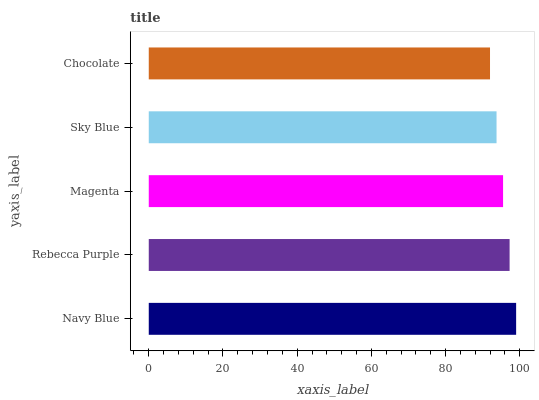Is Chocolate the minimum?
Answer yes or no. Yes. Is Navy Blue the maximum?
Answer yes or no. Yes. Is Rebecca Purple the minimum?
Answer yes or no. No. Is Rebecca Purple the maximum?
Answer yes or no. No. Is Navy Blue greater than Rebecca Purple?
Answer yes or no. Yes. Is Rebecca Purple less than Navy Blue?
Answer yes or no. Yes. Is Rebecca Purple greater than Navy Blue?
Answer yes or no. No. Is Navy Blue less than Rebecca Purple?
Answer yes or no. No. Is Magenta the high median?
Answer yes or no. Yes. Is Magenta the low median?
Answer yes or no. Yes. Is Navy Blue the high median?
Answer yes or no. No. Is Sky Blue the low median?
Answer yes or no. No. 